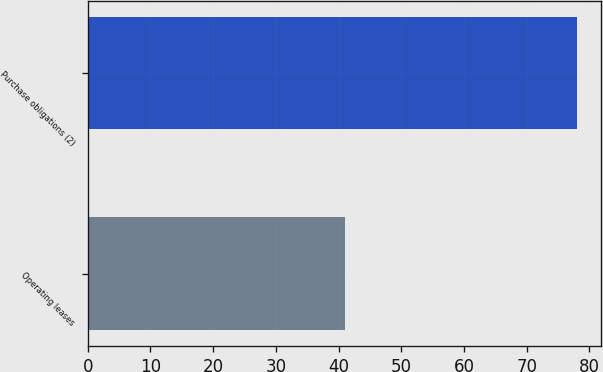Convert chart. <chart><loc_0><loc_0><loc_500><loc_500><bar_chart><fcel>Operating leases<fcel>Purchase obligations (2)<nl><fcel>41<fcel>78<nl></chart> 